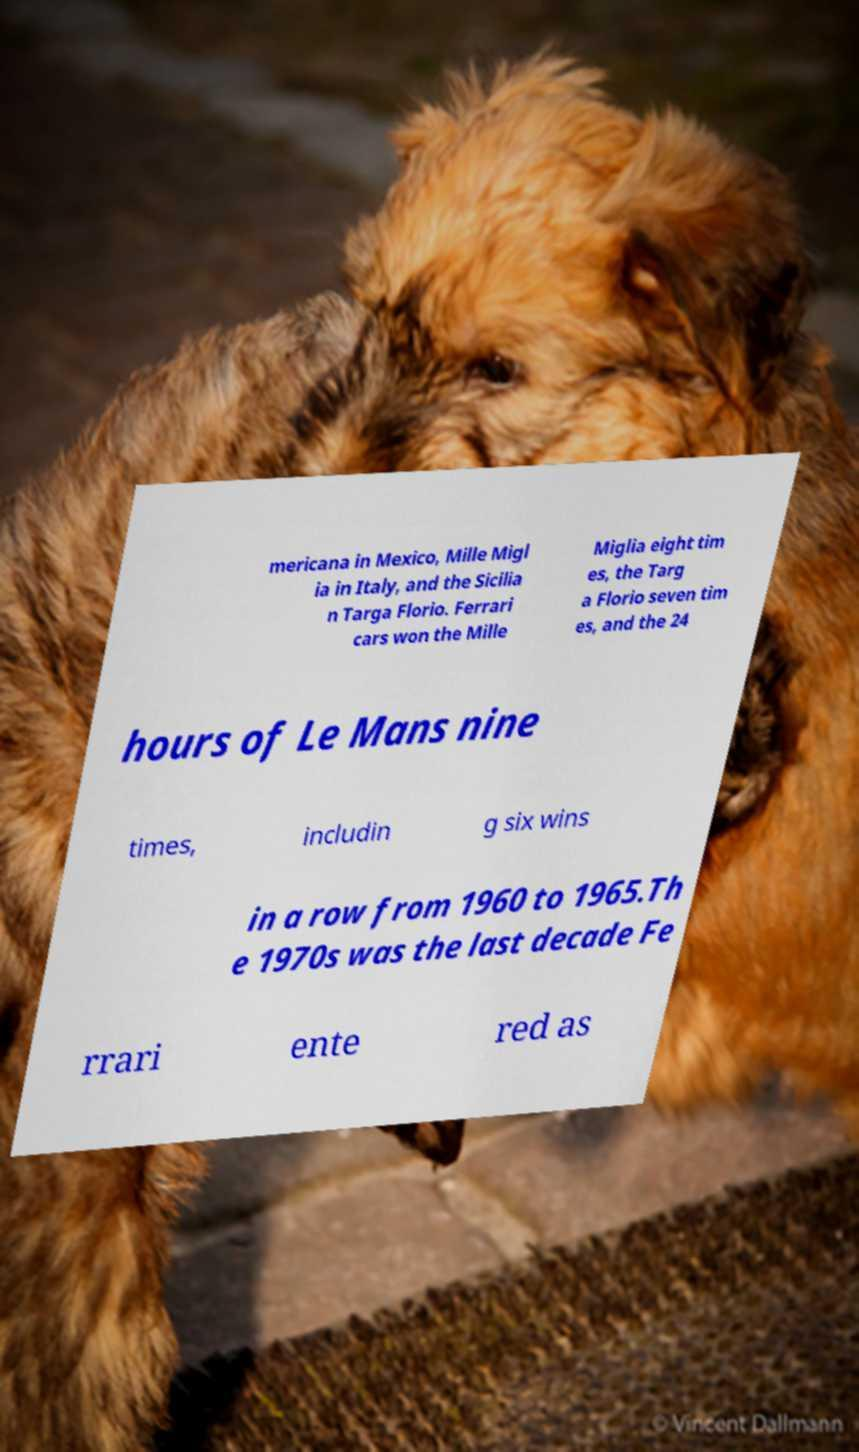Can you read and provide the text displayed in the image?This photo seems to have some interesting text. Can you extract and type it out for me? mericana in Mexico, Mille Migl ia in Italy, and the Sicilia n Targa Florio. Ferrari cars won the Mille Miglia eight tim es, the Targ a Florio seven tim es, and the 24 hours of Le Mans nine times, includin g six wins in a row from 1960 to 1965.Th e 1970s was the last decade Fe rrari ente red as 